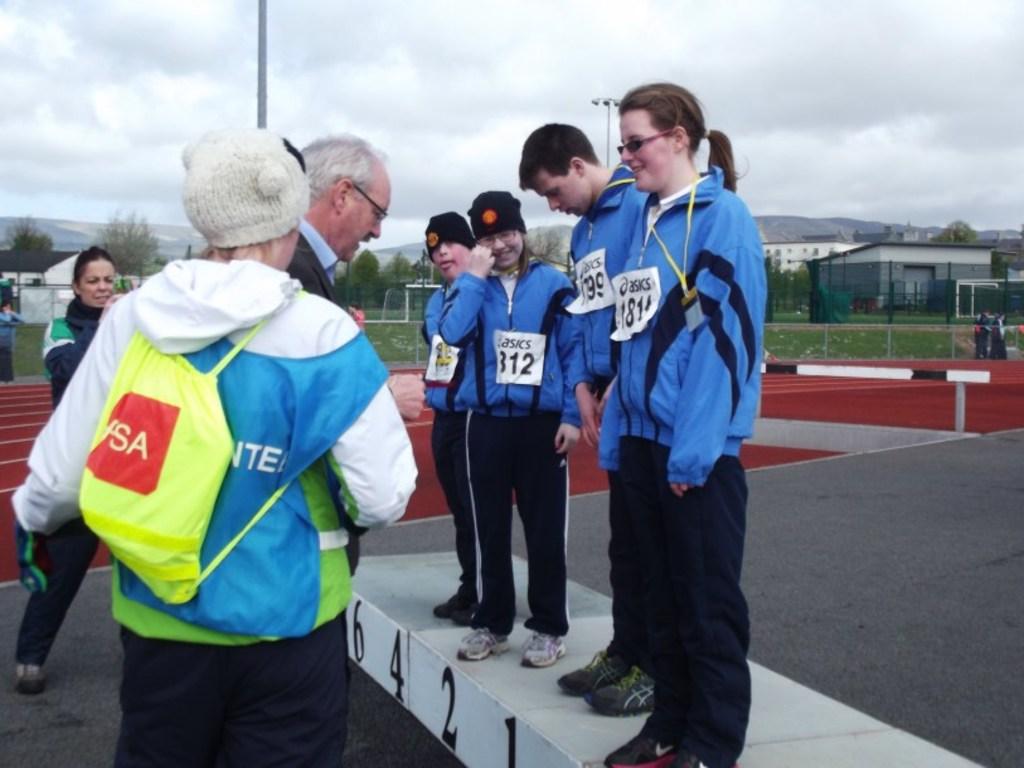What is the number of the girl with a ponytail?
Your answer should be compact. 1811. What are the two letters you can see on the yellow bag?
Offer a terse response. Sa. 